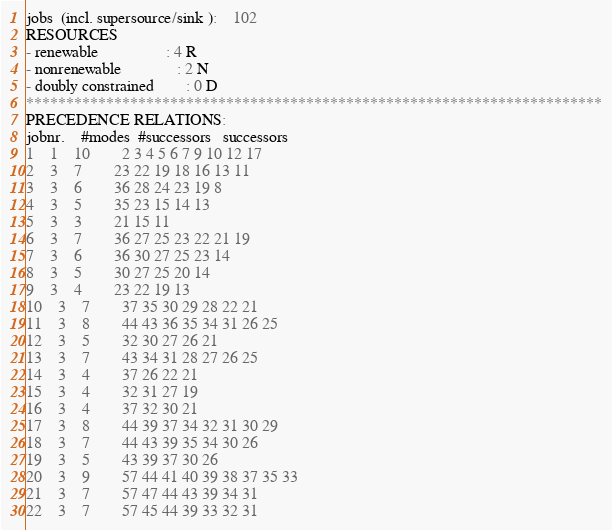Convert code to text. <code><loc_0><loc_0><loc_500><loc_500><_ObjectiveC_>jobs  (incl. supersource/sink ):	102
RESOURCES
- renewable                 : 4 R
- nonrenewable              : 2 N
- doubly constrained        : 0 D
************************************************************************
PRECEDENCE RELATIONS:
jobnr.    #modes  #successors   successors
1	1	10		2 3 4 5 6 7 9 10 12 17 
2	3	7		23 22 19 18 16 13 11 
3	3	6		36 28 24 23 19 8 
4	3	5		35 23 15 14 13 
5	3	3		21 15 11 
6	3	7		36 27 25 23 22 21 19 
7	3	6		36 30 27 25 23 14 
8	3	5		30 27 25 20 14 
9	3	4		23 22 19 13 
10	3	7		37 35 30 29 28 22 21 
11	3	8		44 43 36 35 34 31 26 25 
12	3	5		32 30 27 26 21 
13	3	7		43 34 31 28 27 26 25 
14	3	4		37 26 22 21 
15	3	4		32 31 27 19 
16	3	4		37 32 30 21 
17	3	8		44 39 37 34 32 31 30 29 
18	3	7		44 43 39 35 34 30 26 
19	3	5		43 39 37 30 26 
20	3	9		57 44 41 40 39 38 37 35 33 
21	3	7		57 47 44 43 39 34 31 
22	3	7		57 45 44 39 33 32 31 </code> 